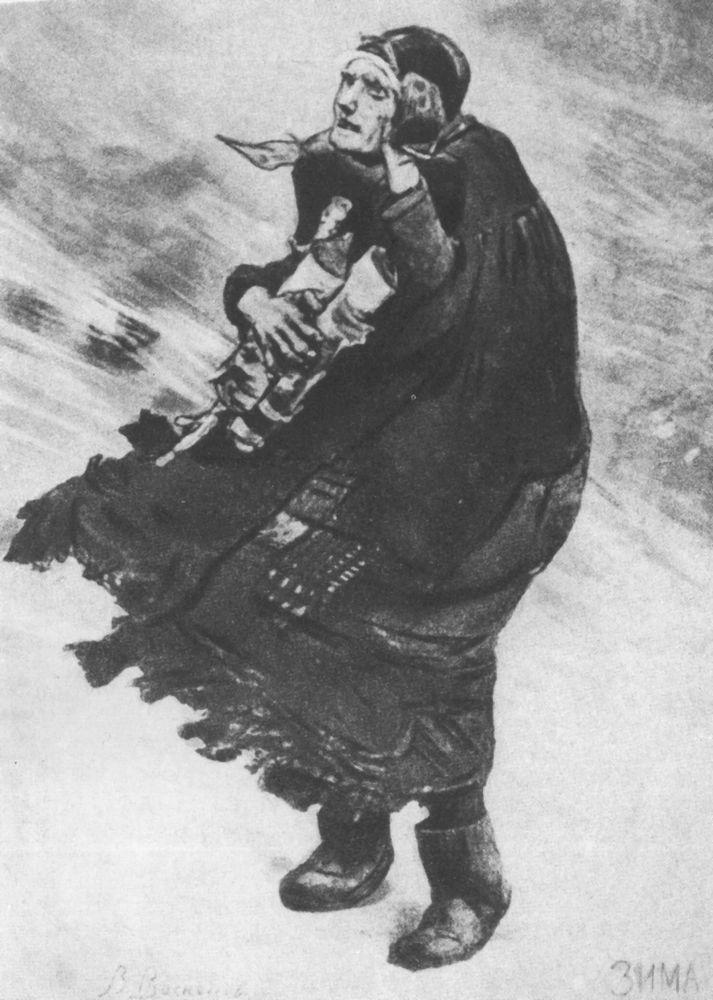What emotions does this image evoke for you? This image evokes a deep sense of empathy, resilience, and maternal love. The stark monochromatic palette combined with the expressive depiction of the woman and child against the relentless backdrop of winter instills a feeling of struggle and determination. The protective manner in which the woman carries the child, despite the harsh conditions, evokes a sense of warmth and tenderness. There's an overwhelming emotion of sacrifice and strength, showcasing the profound bonds of family and the human spirit's capacity to endure against all odds. Create a poetic narrative inspired by this image. In the heart of winter's icy grip, 
A mother battles the biting wind. 
Her heavy cloak, a shield so thin, 
Against the storm, her love pinned. 

Child upon her back, fragile yet brave, 
Holds a token, a cherished toy. 
In her eyes, a fierce fire blazed, 
To protect, to save, her only joy. 

Snow swirls in a chaotic dance, 
Nature’s fury on full display. 
But in her arms, a tender trance, 
A bond unbroken, come what may. 

Silent screams of the tempest loud, 
Yet in their hearts, calm prevails. 
Against all odds, heads unbowed, 
Through the storm, their spirit sails. Describe two potential historical contexts in which this scene might be set. 1. **1910s Eastern Europe:** This scene might take place during a harsh winter in the war-torn regions of Eastern Europe. Amidst the chaos of World War I, many families are displaced, forced to traverse treacherous landscapes in search of safety. The woman, representing countless others, possibly a refugee escaping conflict, embodies the struggle for survival. Her traditional dress and headscarf might hint at her cultural background, highlighting the widespread human cost of war beyond the battlefield. 

2. **1930s Great Depression in Rural North America:** During the Great Depression, many families in rural areas faced extreme poverty and harsh living conditions. This could be a depiction of a mother and child on a perilous journey to a nearby town, seeking assistance or employment. The monochromatic, gritty visual style underscores the era's severe economic hardship. The woman’s determined expression and resilient posture reflect the indomitable spirit of many who endured the Depression, portraying a universal struggle to provide for one's family despite overwhelming odds. Imagine the future of these characters. How does their story evolve after this moment? After braving the relentless winter storm, Elara and Tomas finally arrive at the small town's clinic. The local doctor, moved by their determination, provides immediate care for Tomas, who slowly begins to recover from his illness. Word of their courageous journey spreads throughout the town, and the community rallies to support them, offering food, warm clothing, and shelter. Elara finds work in a local inn, and with the community's support, they start to rebuild their lives. Tomas grows up surrounded by a tight-knit community that respects and admires his mother’s bravery. Years later, as Tomas becomes a young man, he remembers the arduous journey through the snow as a foundational moment that shaped his resilience and understanding of the power of love and community. This photograph, which once captured a moment of despair, now serves as a cherished family heirloom symbolizing perseverance and hope. 